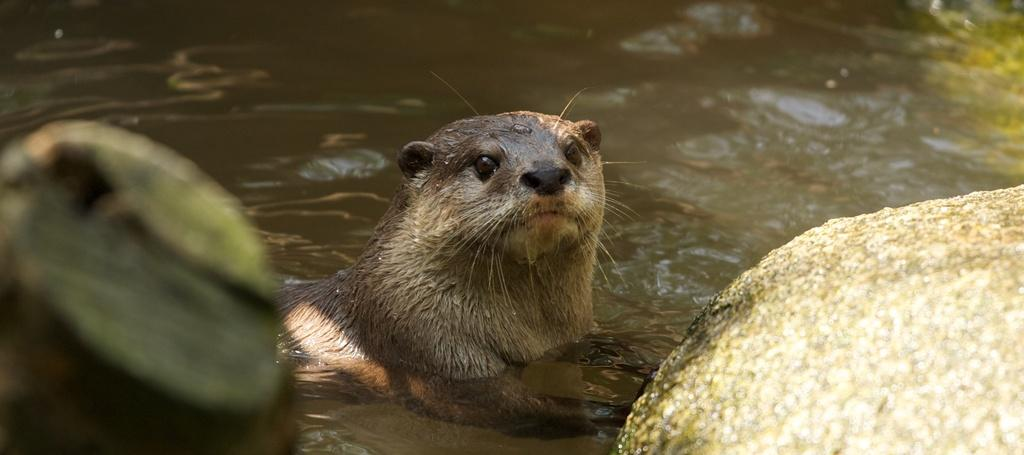What can be seen on the right side of the image? There is a rock on the right side of the image. What type of animal is in the water on the left side of the image? There is an otter in the water on the left side of the image. Can you describe the object that is blurred in the image? Unfortunately, the object that is blurred in the image cannot be described in detail due to its lack of clarity. What type of health benefits can be gained from the rock in the image? The rock in the image is not associated with any health benefits, as it is a natural formation and not a health product. 